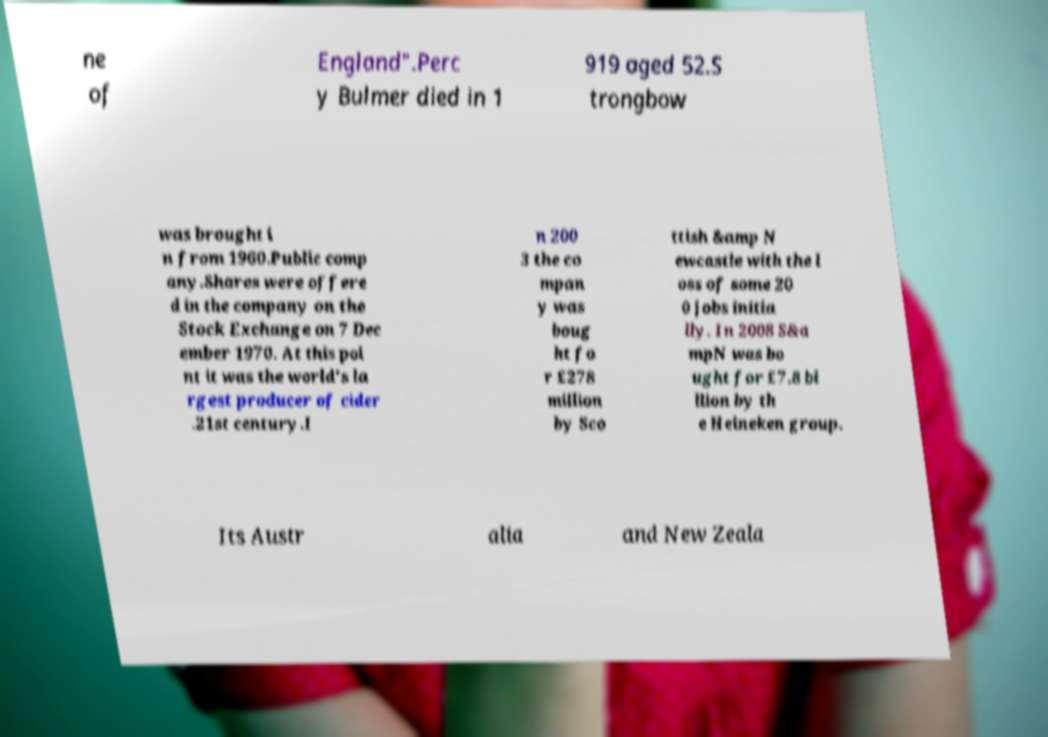Could you assist in decoding the text presented in this image and type it out clearly? ne of England".Perc y Bulmer died in 1 919 aged 52.S trongbow was brought i n from 1960.Public comp any.Shares were offere d in the company on the Stock Exchange on 7 Dec ember 1970. At this poi nt it was the world's la rgest producer of cider .21st century.I n 200 3 the co mpan y was boug ht fo r £278 million by Sco ttish &amp N ewcastle with the l oss of some 20 0 jobs initia lly. In 2008 S&a mpN was bo ught for £7.8 bi llion by th e Heineken group. Its Austr alia and New Zeala 